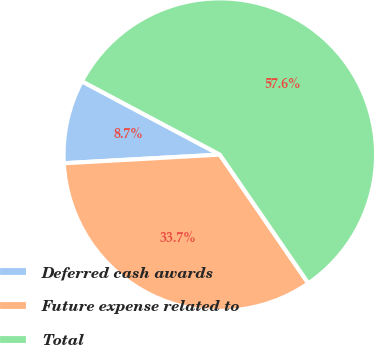Convert chart to OTSL. <chart><loc_0><loc_0><loc_500><loc_500><pie_chart><fcel>Deferred cash awards<fcel>Future expense related to<fcel>Total<nl><fcel>8.66%<fcel>33.71%<fcel>57.63%<nl></chart> 